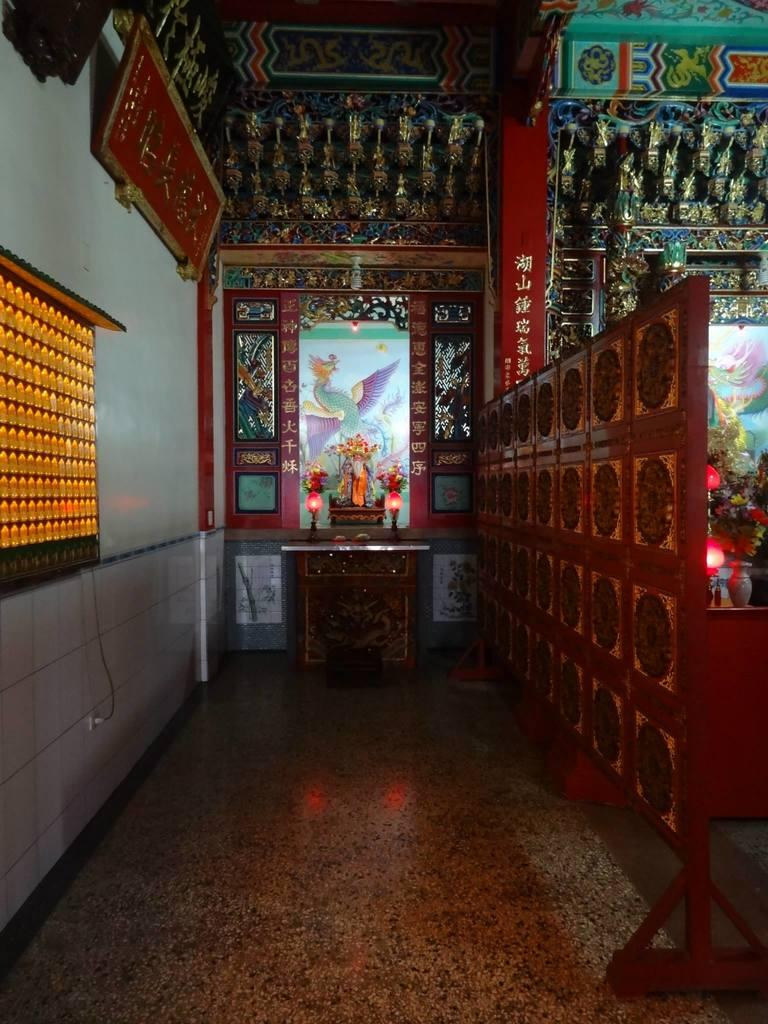What type of objects can be seen in the image? There are boards, metal objects, photo frames, candles, flower pots, and flowers in the image. What other items are present in the image? There are lights and other objects in the image. What is the surface at the bottom of the image? There is a floor at the bottom of the image. Can you see any ducks swimming in the harbor in the image? There is no harbor or ducks present in the image. What type of animals can be seen in the zoo in the image? There is no zoo or animals present in the image. 